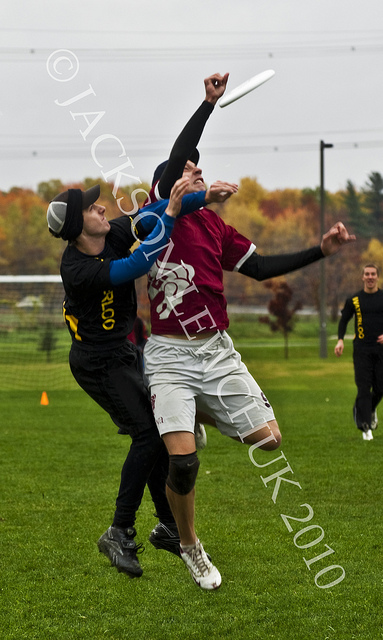Can you describe the activity being depicted in this image? The image captures a moment during a game of Ultimate Frisbee. Two players are in the midst of a competition to catch the flying disc, one dressed in a maroon jersey and the other in a black jersey with yellow highlights. This sport is a non-contact team activity that combines elements of soccer, football, and basketball, all centered around a frisbee. What can you infer about the competition level in the image? Given the intensity visible in the players' expressions and body language, as well as their sporting attire, it suggests that this is a competitive match rather than a casual game. The individuals are focused and appear to be exerting a considerable effort to catch the disc, indicative of a serious play environment. 